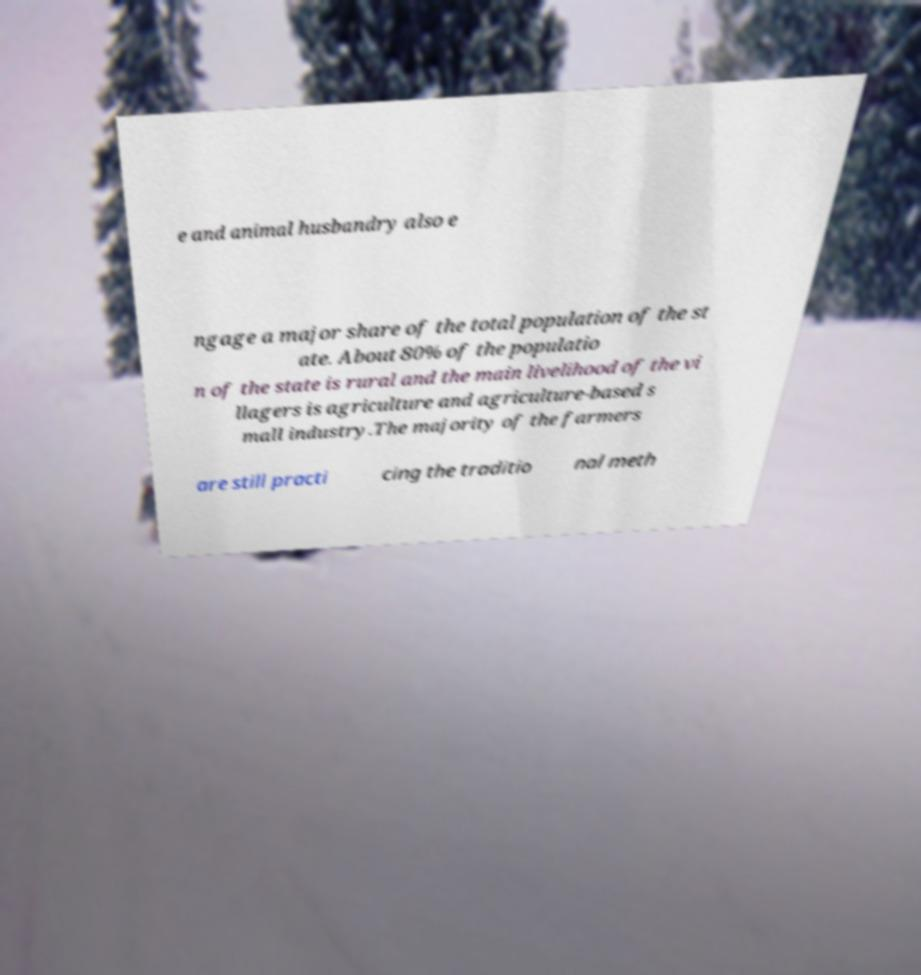I need the written content from this picture converted into text. Can you do that? e and animal husbandry also e ngage a major share of the total population of the st ate. About 80% of the populatio n of the state is rural and the main livelihood of the vi llagers is agriculture and agriculture-based s mall industry.The majority of the farmers are still practi cing the traditio nal meth 